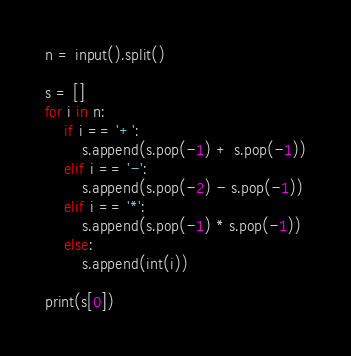Convert code to text. <code><loc_0><loc_0><loc_500><loc_500><_Python_>n = input().split()

s = []
for i in n:
    if i == '+':
        s.append(s.pop(-1) + s.pop(-1))
    elif i == '-':
        s.append(s.pop(-2) - s.pop(-1))
    elif i == '*':
        s.append(s.pop(-1) * s.pop(-1))
    else:
        s.append(int(i))

print(s[0])
</code> 